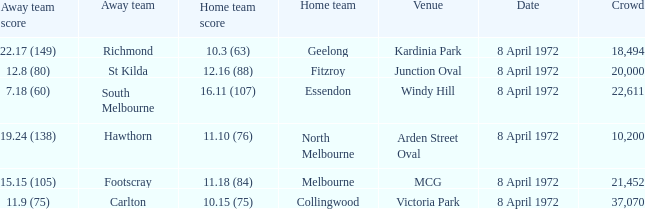Which Venue has a Home team of geelong? Kardinia Park. 